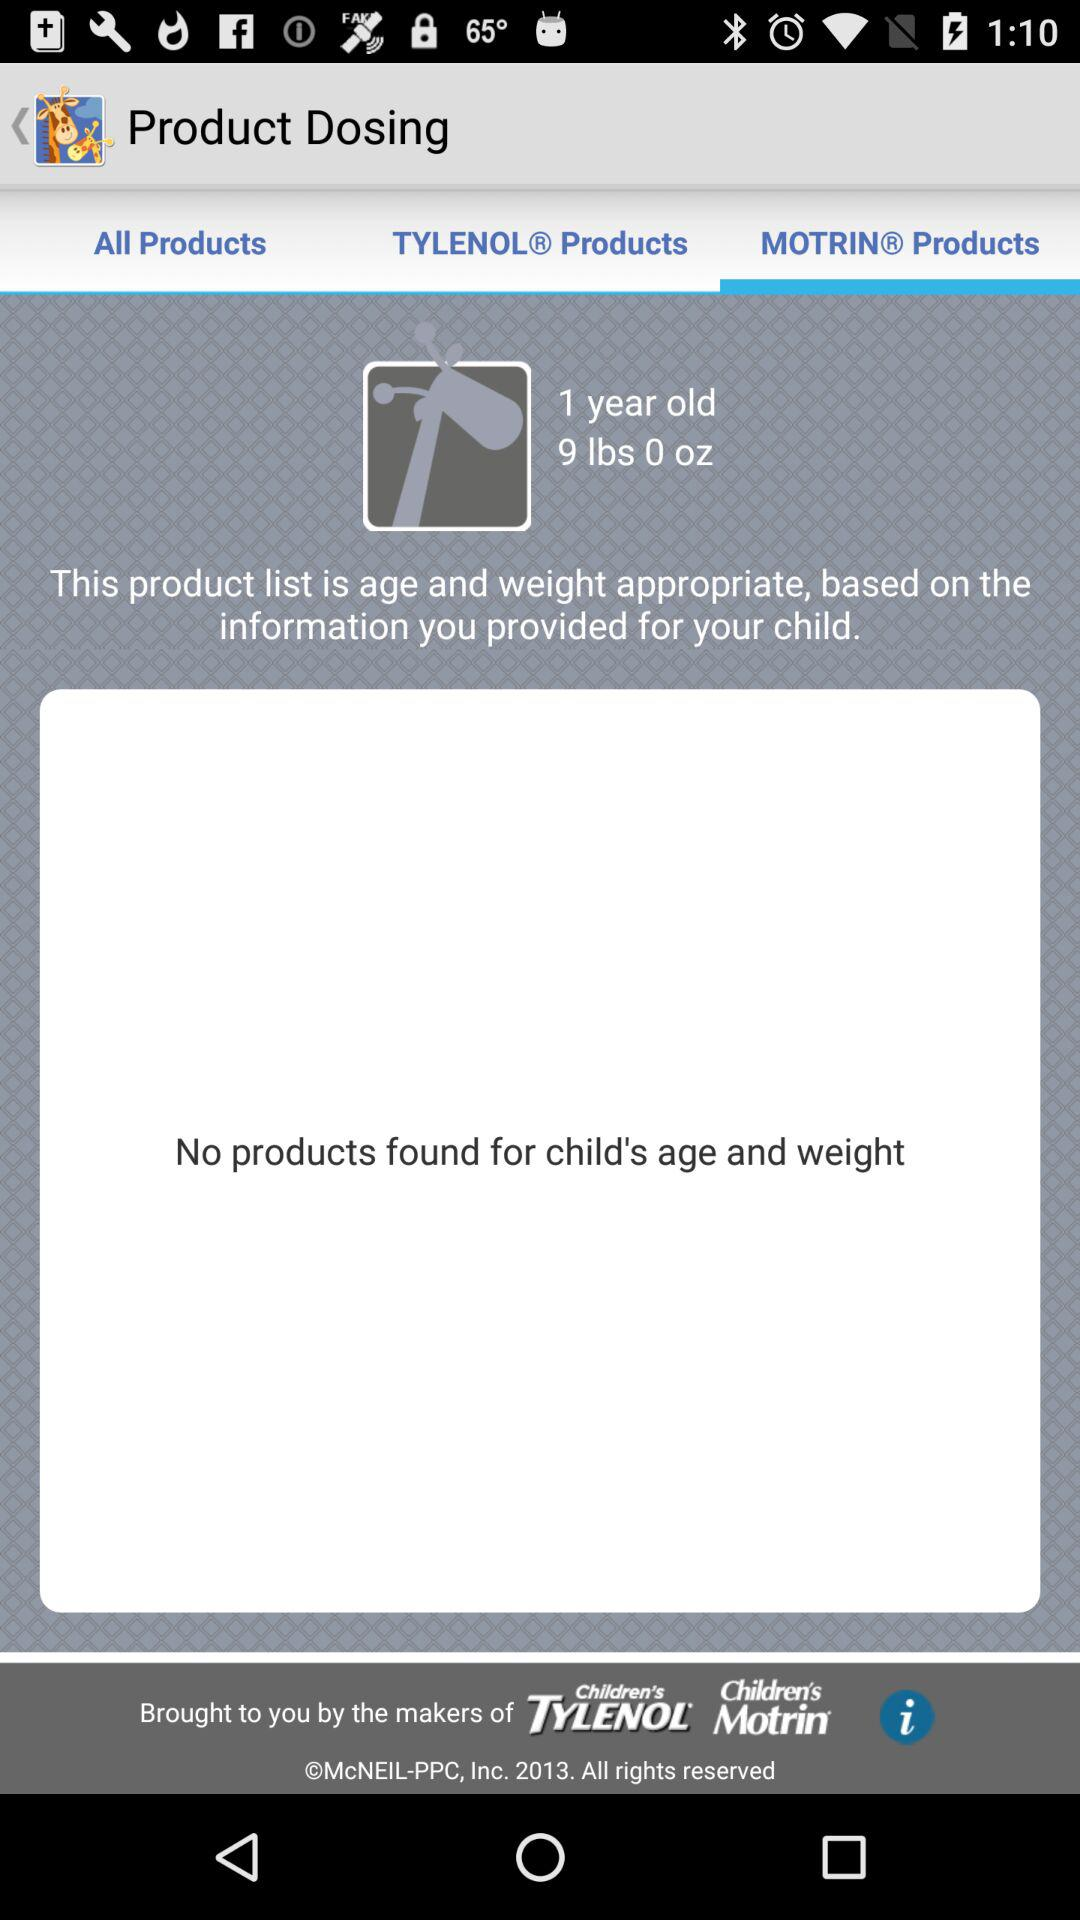How many products are available for a 1 year old child weighing 9 lbs?
Answer the question using a single word or phrase. 0 